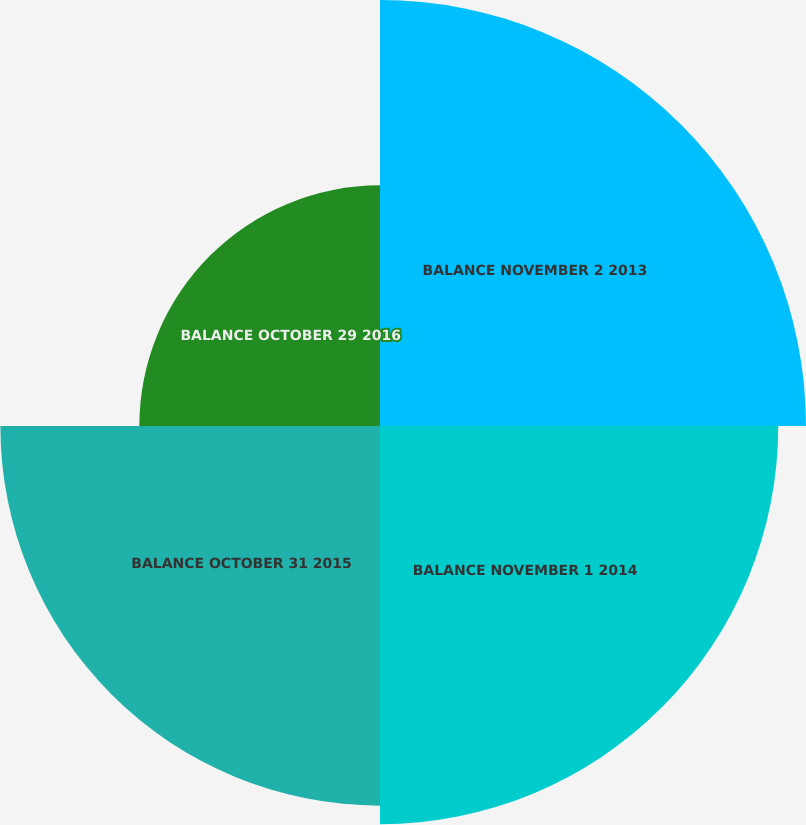<chart> <loc_0><loc_0><loc_500><loc_500><pie_chart><fcel>BALANCE NOVEMBER 2 2013<fcel>BALANCE NOVEMBER 1 2014<fcel>BALANCE OCTOBER 31 2015<fcel>BALANCE OCTOBER 29 2016<nl><fcel>29.49%<fcel>27.57%<fcel>26.28%<fcel>16.66%<nl></chart> 